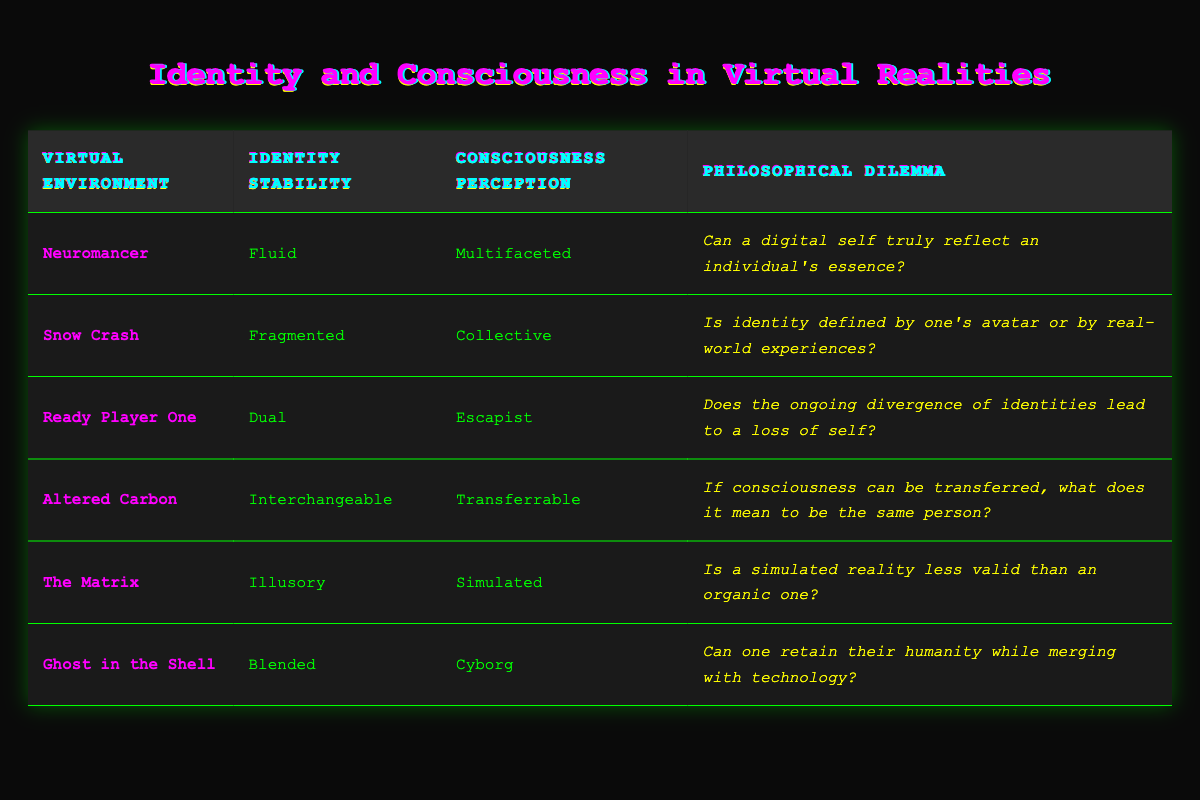What is the identity stability in "Neuromancer"? In the table, the row for "Neuromancer" under the "Identity Stability" column states "Fluid".
Answer: Fluid What are the consciousness perceptions listed for "Ready Player One"? Referring to the row for "Ready Player One," the "Consciousness Perception" column lists it as "Escapist".
Answer: Escapist Is "The Matrix" classified as having an illusory identity stability? The "Identity Stability" for "The Matrix" in the table is "Illusory", confirming that it is classified as illusory.
Answer: Yes How many virtual environments listed have a consciousness perception categorized as "Collective"? Looking through the table, only "Snow Crash" has a consciousness perception labeled "Collective". Therefore, the count is 1.
Answer: 1 What is the philosophical dilemma associated with "Altered Carbon"? In the table, the row for "Altered Carbon" shows that the philosophical dilemma is "If consciousness can be transferred, what does it mean to be the same person?"
Answer: If consciousness can be transferred, what does it mean to be the same person? Which virtual environments combine identity stability and consciousness perception into a blended or transferable category? "Ghost in the Shell" combines "Blended" identity stability with "Cyborg" consciousness perception, while "Altered Carbon" combines "Interchangeable" identity stability with "Transferrable" consciousness perception.
Answer: Ghost in the Shell and Altered Carbon If we consider the average identity stability from the table categories listed (Fluid, Fragmented, Dual, Interchangeable, Illusory, Blended), does it lean towards more chaotic or structured definitions? Analyzing the terms, "Fluid", "Fragmented", "Dual", and "Illusory" suggest chaos, while "Interchangeable" and "Blended" have more structure. Since there are more chaotic terms, it leans towards chaotic.
Answer: Chaotic Does "Ready Player One" present a dilemma about the loss of self resulting from the divergence of identities? The table indicates that the philosophical dilemma for "Ready Player One" is indeed about whether the ongoing divergence of identities leads to a loss of self.
Answer: Yes How does the consciousness perception of "Ghost in the Shell" differ from that of "Neuromancer"? The perception for "Ghost in the Shell" is "Cyborg" while "Neuromancer" is described as "Multifaceted". This shows that "Ghost in the Shell" focuses on the integration of human and technology, whereas "Neuromancer" suggests complexity in identity.
Answer: Different perceptions; Cyborg vs. Multifaceted 